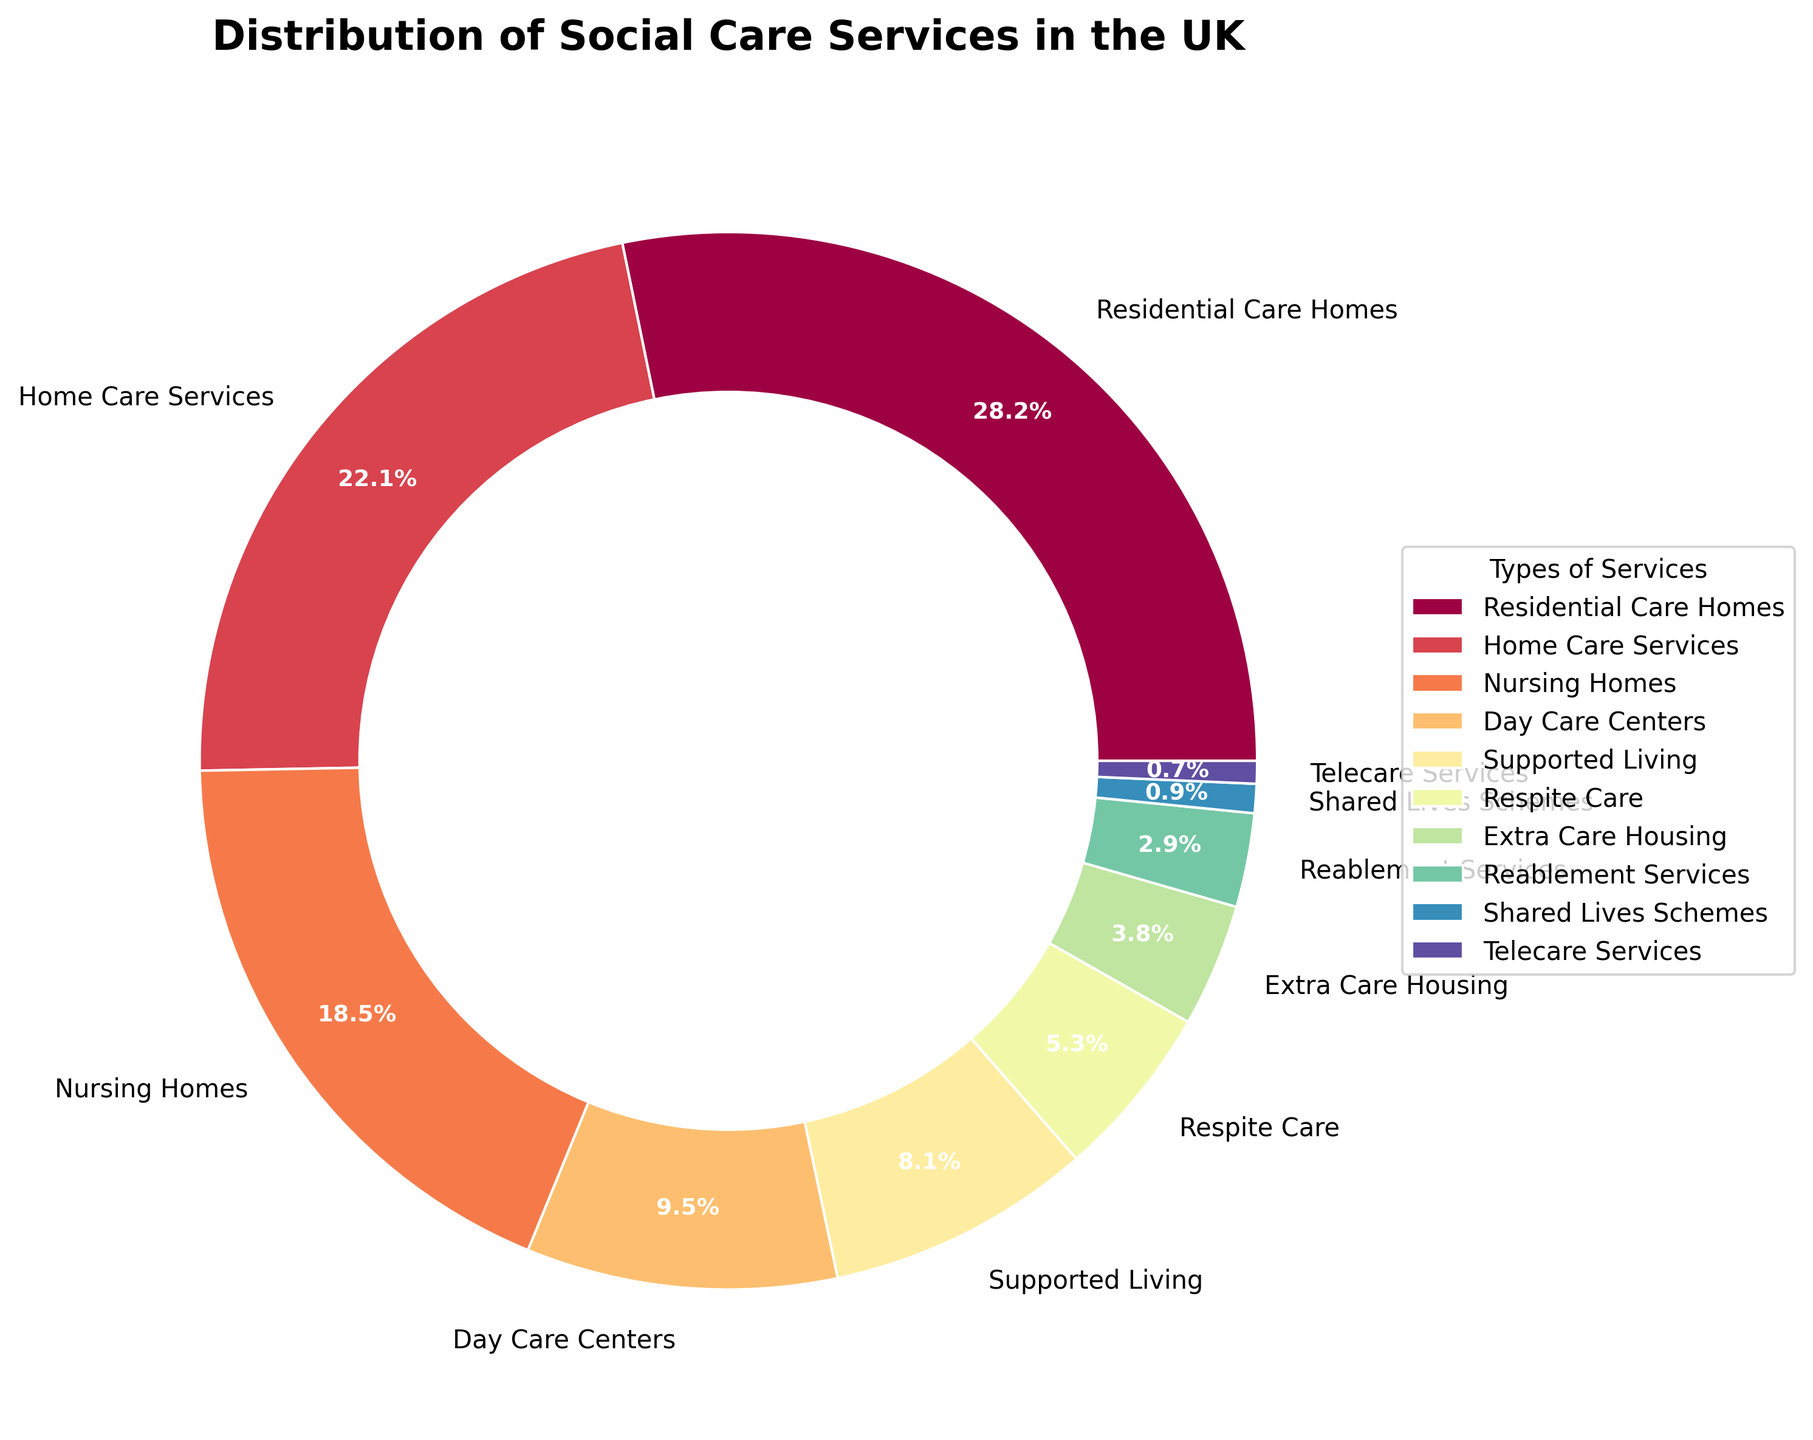Which type of social care service has the highest percentage? According to the pie chart, Residential Care Homes occupy the largest segment of the chart.
Answer: Residential Care Homes What is the total percentage of services provided by Home Care Services and Nursing Homes combined? Home Care Services account for 22.3% and Nursing Homes for 18.7%. Adding these together, 22.3% + 18.7% = 41.0%.
Answer: 41.0% Which services have a lower percentage than Supported Living? Supported Living has a percentage of 8.2%. The services with lower percentages are Respite Care (5.4%), Extra Care Housing (3.8%), Reablement Services (2.9%), Shared Lives Schemes (0.9%), and Telecare Services (0.7%).
Answer: Respite Care, Extra Care Housing, Reablement Services, Shared Lives Schemes, Telecare Services How much more percentage does Residential Care Homes have compared to Day Care Centers? Residential Care Homes account for 28.5% and Day Care Centers for 9.6%. Subtracting these, 28.5% - 9.6% = 18.9%.
Answer: 18.9% Which type of social care service occupies the smallest segment of the chart? The smallest segment of the pie chart is occupied by Telecare Services.
Answer: Telecare Services What is the sum of the percentages of services that each make up less than 5% of the total distribution? Services that make up less than 5% are Respite Care (5.4%), Extra Care Housing (3.8%), Reablement Services (2.9%), Shared Lives Schemes (0.9%), and Telecare Services (0.7%). Adding these together: 5.4% + 3.8% + 2.9% + 0.9% + 0.7% = 13.7%.
Answer: 13.7% Which two types of services have almost the same percentage, and what are their values? Home Care Services (22.3%) and Nursing Homes (18.7%) are relatively close in percentage, but not the same. Supported Living (8.2%) and Day Care Centers (9.6%) have closer percentages.
Answer: Supported Living and Day Care Centers; 8.2%, 9.6% By how much does the percentage of Residential Care Homes exceed the combined percentage of Telecare Services and Shared Lives Schemes? Residential Care Homes have 28.5%, while Telecare Services and Shared Lives Schemes combined have 0.7% + 0.9% = 1.6%. The difference is 28.5% - 1.6% = 26.9%.
Answer: 26.9% What is the average percentage of the top three types of social care services? The top three services by percentage are Residential Care Homes (28.5%), Home Care Services (22.3%), and Nursing Homes (18.7%). The average is calculated as (28.5 + 22.3 + 18.7) / 3 = 69.5 / 3 = 23.17%.
Answer: 23.17% What services fall under the 10% mark in the pie chart? The services under 10% are Day Care Centers (9.6%), Supported Living (8.2%), Respite Care (5.4%), Extra Care Housing (3.8%), Reablement Services (2.9%), Shared Lives Schemes (0.9%), and Telecare Services (0.7%).
Answer: Day Care Centers, Supported Living, Respite Care, Extra Care Housing, Reablement Services, Shared Lives Schemes, Telecare Services 